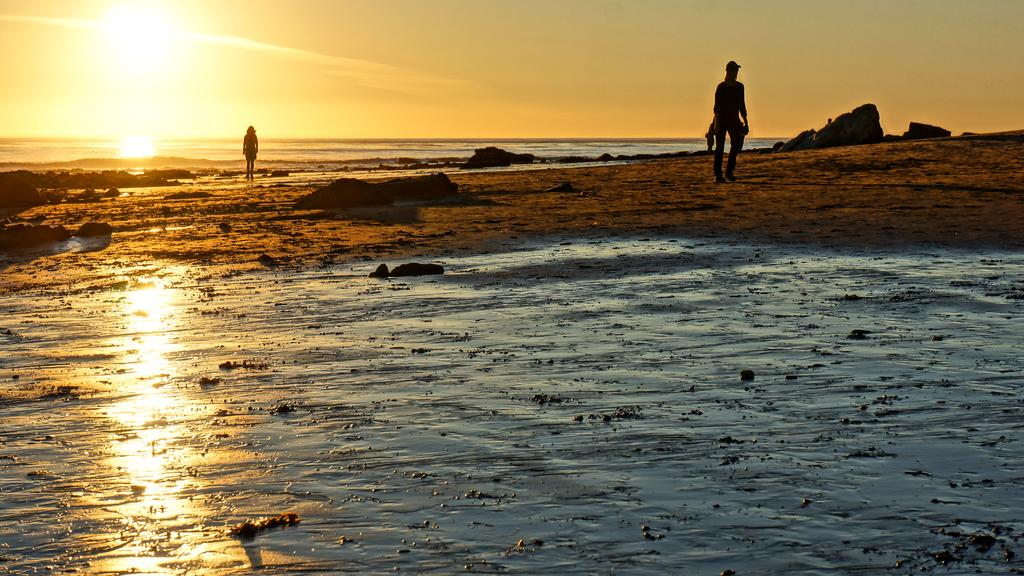How many people are in the image? There are two persons in the image. Where is the image set? The image is set in a beach. What can be seen in the background of the image? There is a sunrise visible in the background of the image. What type of ticket is being sold at the beach party in the image? There is no beach party or ticket present in the image; it is set in a beach with a sunrise in the background. 